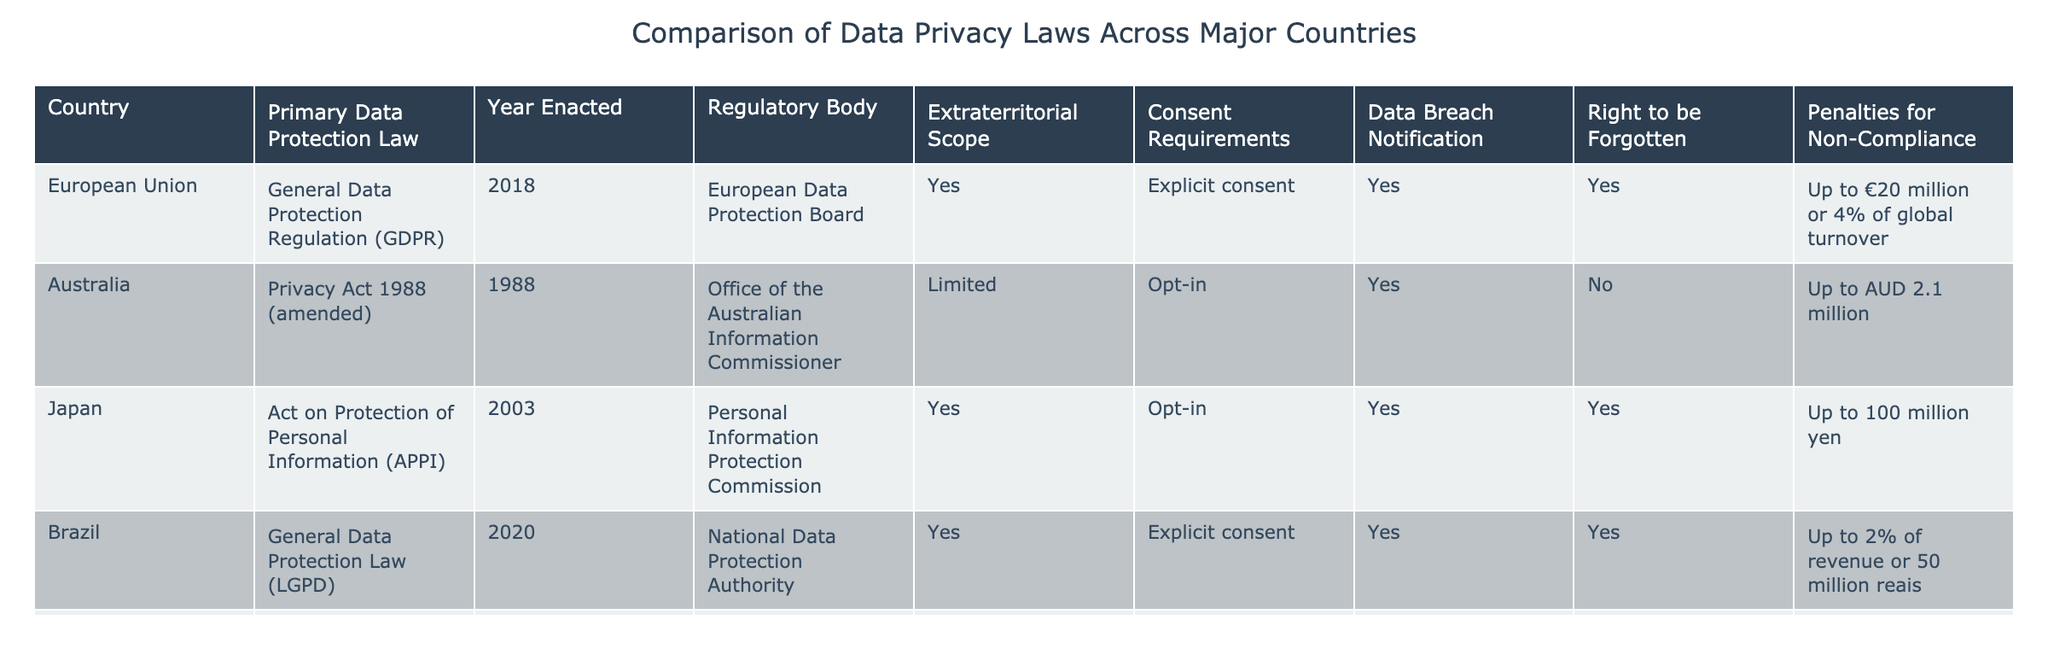What's the primary data protection law of India? The table lists India under the column "Primary Data Protection Law," showing "Personal Data Protection Bill (pending)" as the law applicable.
Answer: Personal Data Protection Bill (pending) Which regulatory body oversees the General Data Protection Regulation (GDPR)? The table indicates that the "European Data Protection Board" is the regulatory body for the GDPR in the corresponding column.
Answer: European Data Protection Board Does Brazil's General Data Protection Law (LGPD) require explicit consent? By examining the "Consent Requirements" column for Brazil, it states "Explicit consent," confirming that it does require this type of consent.
Answer: Yes What are the penalties for non-compliance with the Personal Information Protection Law (PIPL) in China? The table shows the penalties listed for China under the "Penalties for Non-Compliance" column, which states "Up to 50 million yuan or 5% of annual revenue."
Answer: Up to 50 million yuan or 5% of annual revenue Which country has a data protection law enacted most recently, and what is the name of that law? Reviewing the "Year Enacted" column, Brazil's law from 2020 stands as the most recent. The corresponding law in the "Primary Data Protection Law" column is the LGPD.
Answer: Brazil, General Data Protection Law (LGPD) How many countries have a "Right to be Forgotten" provision in their data protection laws? The countries listed under the "Right to be Forgotten" column show four entries marked "Yes," specifically EU, Japan, Brazil, and India.
Answer: Four countries Which country has the least severe penalties for non-compliance? By looking at the "Penalties for Non-Compliance" column, Singapore lists penalties of up to SGD 1 million, which is less severe than the other penalties mentioned.
Answer: Singapore Does the Personal Data Protection Act (PDPA) in Singapore require explicit consent for data processing? The "Consent Requirements" column for Singapore indicates "Opt-in," suggesting it does not require explicit consent, only a general agreement.
Answer: No Which two countries have the same level of extraterritorial scope? The "Extraterritorial Scope" column shows both Australia and South Korea marked as "Limited," indicating they share this characteristic.
Answer: Australia and South Korea What is the average penalty for non-compliance among the listed countries? To calculate the average, sum the penalty values: (20 million + 2.1 million + ~930,000 + 50 million + 50 million + ~1.8 million + 2 million + 100 million) and divide by the number of countries which is 8. This yields an average of approximately 29.6 million (with approximate conversions).
Answer: Approximately 29.6 million 